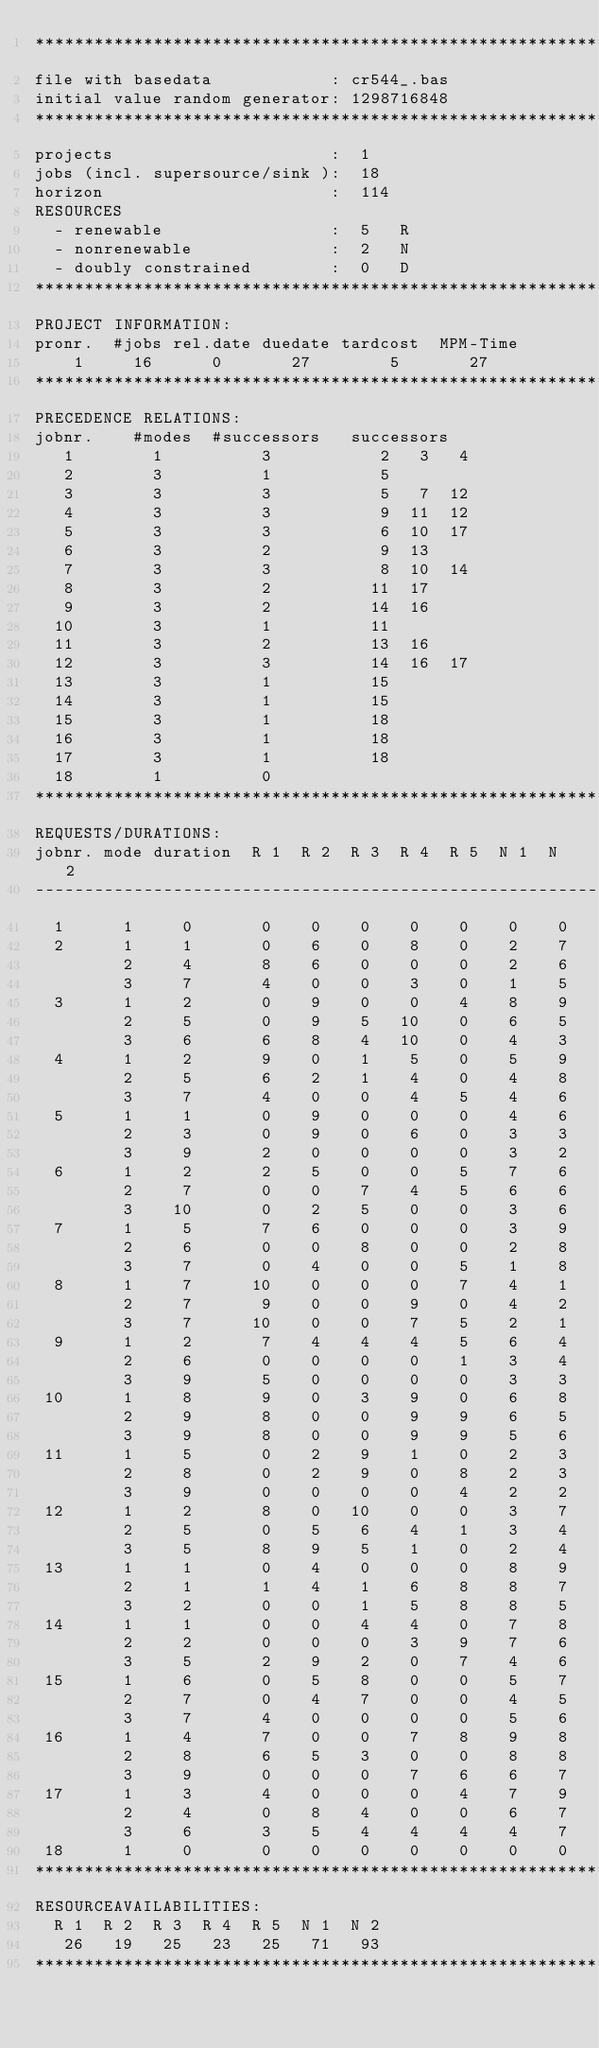Convert code to text. <code><loc_0><loc_0><loc_500><loc_500><_ObjectiveC_>************************************************************************
file with basedata            : cr544_.bas
initial value random generator: 1298716848
************************************************************************
projects                      :  1
jobs (incl. supersource/sink ):  18
horizon                       :  114
RESOURCES
  - renewable                 :  5   R
  - nonrenewable              :  2   N
  - doubly constrained        :  0   D
************************************************************************
PROJECT INFORMATION:
pronr.  #jobs rel.date duedate tardcost  MPM-Time
    1     16      0       27        5       27
************************************************************************
PRECEDENCE RELATIONS:
jobnr.    #modes  #successors   successors
   1        1          3           2   3   4
   2        3          1           5
   3        3          3           5   7  12
   4        3          3           9  11  12
   5        3          3           6  10  17
   6        3          2           9  13
   7        3          3           8  10  14
   8        3          2          11  17
   9        3          2          14  16
  10        3          1          11
  11        3          2          13  16
  12        3          3          14  16  17
  13        3          1          15
  14        3          1          15
  15        3          1          18
  16        3          1          18
  17        3          1          18
  18        1          0        
************************************************************************
REQUESTS/DURATIONS:
jobnr. mode duration  R 1  R 2  R 3  R 4  R 5  N 1  N 2
------------------------------------------------------------------------
  1      1     0       0    0    0    0    0    0    0
  2      1     1       0    6    0    8    0    2    7
         2     4       8    6    0    0    0    2    6
         3     7       4    0    0    3    0    1    5
  3      1     2       0    9    0    0    4    8    9
         2     5       0    9    5   10    0    6    5
         3     6       6    8    4   10    0    4    3
  4      1     2       9    0    1    5    0    5    9
         2     5       6    2    1    4    0    4    8
         3     7       4    0    0    4    5    4    6
  5      1     1       0    9    0    0    0    4    6
         2     3       0    9    0    6    0    3    3
         3     9       2    0    0    0    0    3    2
  6      1     2       2    5    0    0    5    7    6
         2     7       0    0    7    4    5    6    6
         3    10       0    2    5    0    0    3    6
  7      1     5       7    6    0    0    0    3    9
         2     6       0    0    8    0    0    2    8
         3     7       0    4    0    0    5    1    8
  8      1     7      10    0    0    0    7    4    1
         2     7       9    0    0    9    0    4    2
         3     7      10    0    0    7    5    2    1
  9      1     2       7    4    4    4    5    6    4
         2     6       0    0    0    0    1    3    4
         3     9       5    0    0    0    0    3    3
 10      1     8       9    0    3    9    0    6    8
         2     9       8    0    0    9    9    6    5
         3     9       8    0    0    9    9    5    6
 11      1     5       0    2    9    1    0    2    3
         2     8       0    2    9    0    8    2    3
         3     9       0    0    0    0    4    2    2
 12      1     2       8    0   10    0    0    3    7
         2     5       0    5    6    4    1    3    4
         3     5       8    9    5    1    0    2    4
 13      1     1       0    4    0    0    0    8    9
         2     1       1    4    1    6    8    8    7
         3     2       0    0    1    5    8    8    5
 14      1     1       0    0    4    4    0    7    8
         2     2       0    0    0    3    9    7    6
         3     5       2    9    2    0    7    4    6
 15      1     6       0    5    8    0    0    5    7
         2     7       0    4    7    0    0    4    5
         3     7       4    0    0    0    0    5    6
 16      1     4       7    0    0    7    8    9    8
         2     8       6    5    3    0    0    8    8
         3     9       0    0    0    7    6    6    7
 17      1     3       4    0    0    0    4    7    9
         2     4       0    8    4    0    0    6    7
         3     6       3    5    4    4    4    4    7
 18      1     0       0    0    0    0    0    0    0
************************************************************************
RESOURCEAVAILABILITIES:
  R 1  R 2  R 3  R 4  R 5  N 1  N 2
   26   19   25   23   25   71   93
************************************************************************
</code> 